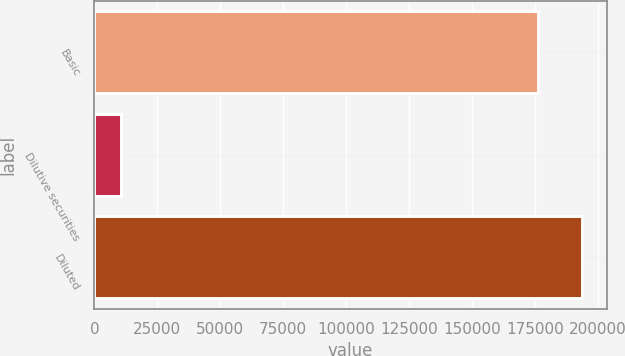Convert chart. <chart><loc_0><loc_0><loc_500><loc_500><bar_chart><fcel>Basic<fcel>Dilutive securities<fcel>Diluted<nl><fcel>176212<fcel>10462<fcel>193833<nl></chart> 